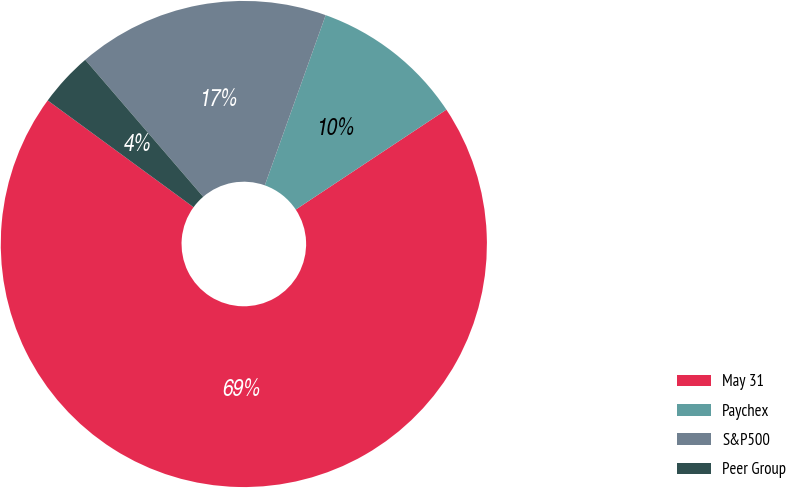Convert chart. <chart><loc_0><loc_0><loc_500><loc_500><pie_chart><fcel>May 31<fcel>Paychex<fcel>S&P500<fcel>Peer Group<nl><fcel>69.37%<fcel>10.21%<fcel>16.78%<fcel>3.63%<nl></chart> 